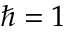Convert formula to latex. <formula><loc_0><loc_0><loc_500><loc_500>\hbar { = } 1</formula> 